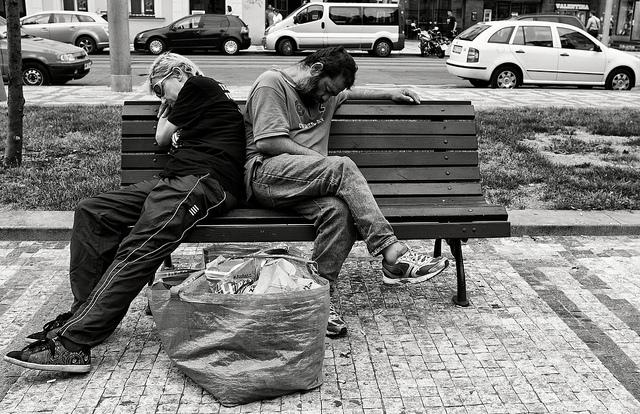What vehicle on the north side of the street will the car traveling west pass second?

Choices:
A) motorcycle
B) light 4-door
C) white van
D) black 4-door white van 